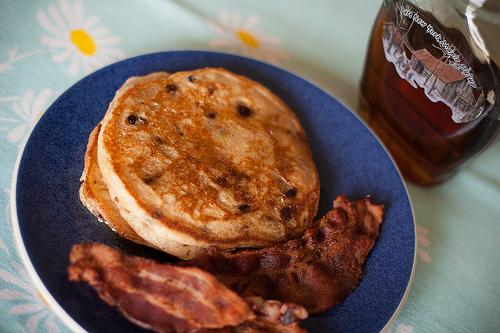What is the most eye-catching element in the image?  The delightful combination of blueberry pancakes stacked with crispy bacon on the bright blue plate captures the viewer's attention effortlessly. Briefly discuss the details of the table setting in this image. The table is adorned with a baby blue floral tablecloth echoing softness and warmth, while a white daisy with a yellow center complements the overall color scheme. Express what you see in this indoor breakfast scene in a casual tone. Wow, that's a tasty-looking brekkie! Blueberry pancakes, crispy bacon, a cute white flower, all set on a lovely light blue tablecloth. And don't forget the maple syrup, yum! Focus on the intricate details of the pancakes in the image. The two brown chocolate chip pancakes are embellished with delectable blueberries and have a slightly uneven surface, making them look authentically homemade. Narrate the presentation of food on this breakfast plate. On a ceramic blue plate, there lie two delicious blueberry pancakes, topped with two crispy pieces of bacon, creating a mouth-watering sight for breakfast. Write like an interior designer talking about the image's color harmony. The harmonious blend of soft blues and warm-toned breakfast items creates a calming ambiance, skillfully balancing the composition of this cozy indoor scene. Elaborate on the unique features of the bacon. There are two slices of bacon, one crispy and one chewy, both placed underneath the pancakes. They have a slightly wrinkly appearance. Describe the bottle of syrup in a marketing tone. Indulge in this glass bottle of authentic maple syrup from New York, adorned with an illustration of a charming log cabin, perfect for drizzling over your pancakes. In a poetic manner, describe the image's contents. A sweet symphony of flavors, where blueberry pancakes dance with crispy bacon, a white daisy whispers to the morning light, and maple syrup lingers, waiting to join the feast. Mention the key components of this breakfast image. Blue plate, pancakes with blueberries, two slices of bacon, white daisy, light blue tablecloth, and a bottle of maple syrup. Can you spot the stack of pancakes with strawberries on top? There are pancakes in the image, but they have blueberries, not strawberries. Is there a cat sitting beside the pancakes on the blue plate? There is no cat in the image, only food items and a floral tablecloth. Examine the broken glass on the table near the bacon. There is no broken glass in the image, only food items and the table setting. Focus on the vibrant orange flower with a yellow center. The flower in the image is a white daisy, not an orange flower. Are there any sprinkles on the pancakes? There are no sprinkles featured in the image—just blueberries and a chocolate chip in the pancakes. Notice the giant moose in front of the maple syrup bottle.  There is no moose in the picture; there is an illustration of a cabin on the syrup bottle. Do the purple polka dot tablecloth and the daisy complement each other? The tablecloth is not purple with polka dots, but light blue with a floral pattern. Look for the three eggs over easy next to the bacon on the plate. There are no eggs in the picture, just pancakes, bacon, and a flower on the table. Observe the plate of bacon and fried chicken placed next to each other. There is no fried chicken in the image, only two slices of bacon on the plate. Find the green plate with breakfast on it. There is no green plate in the image; the plate is blue. 